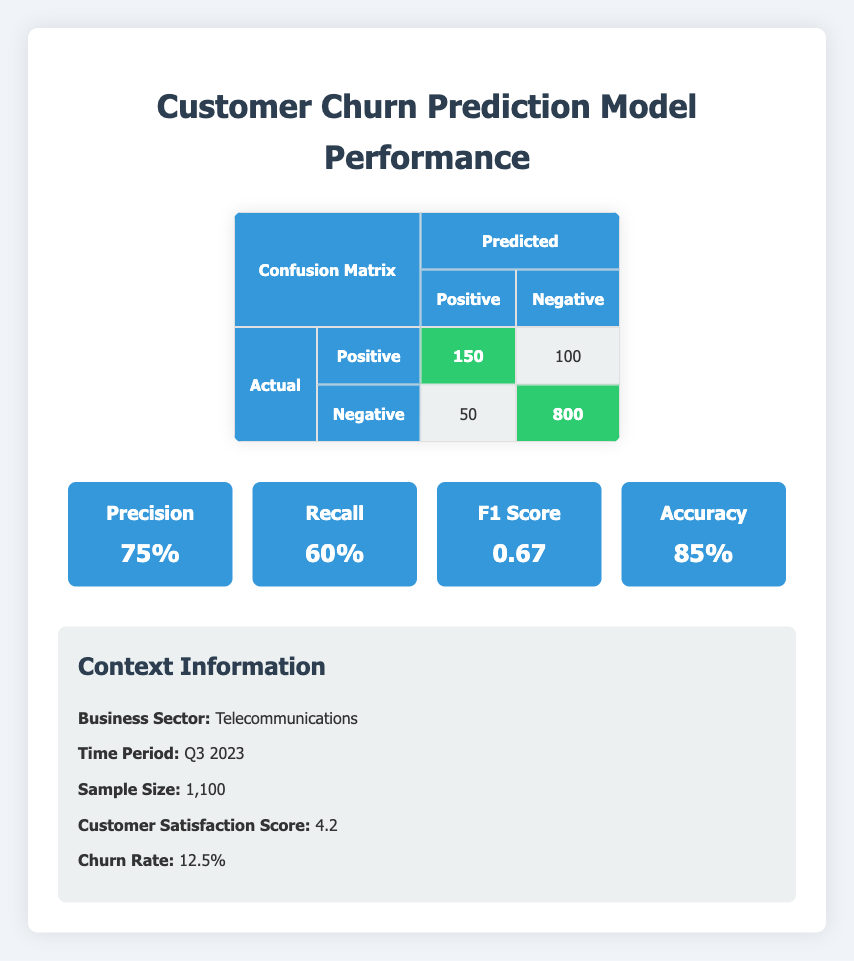What is the value of True Positive? The True Positive is indicated in the confusion matrix and is the count of correctly predicted positive cases, which is shown as 150.
Answer: 150 What is the Total number of False Negatives? The confusion matrix lists False Negatives as the number of cases incorrectly predicted to be negative, which is specified as 100.
Answer: 100 Based on the metrics, what is the Precision of the model? Precision is calculated as True Positives divided by the sum of True Positives and False Positives. From the table, True Positives is 150 and False Positives is 50, thus precision = 150 / (150 + 50) = 0.75 or 75%.
Answer: 75% What is the Accuracy of the model? Accuracy combines both True Positives and True Negatives divided by the total observations. Here, True Positives is 150, True Negatives is 800, and the total sample size is 1,100. The calculation is (150 + 800) / 1100 = 0.85 or 85%.
Answer: 85% True or False: The Recall of the model is greater than the Precision. Recall is given as 60% and Precision as 75%. Since 60% is not greater than 75%, the statement is false.
Answer: False What is the total number of customers predicted to churn? The number of customers predicted to churn corresponds to the sum of True Positives and False Negatives in the confusion matrix. True Positives is 150 and False Negatives is 100, so total predicted churn = 150 + 100 = 250.
Answer: 250 How many customers were accurately predicted not to churn? The number of customers accurately predicted not to churn is represented by True Negatives, which is shown in the matrix as 800.
Answer: 800 If we consider the Churn Rate, what percentage of the sample size does the True Positive represent? The True Positive count is 150 and the sample size is 1,100. To find the percentage, divide 150 by 1100 and multiply by 100. This results in (150/1100) * 100 ≈ 13.64%.
Answer: 13.64% What is the F1 Score of the model, and what does it indicate? The F1 Score is provided as 0.67 and represents a balance between precision and recall. It indicates how well the model performs in identifying positive cases, especially when the class distribution is uneven.
Answer: 0.67 